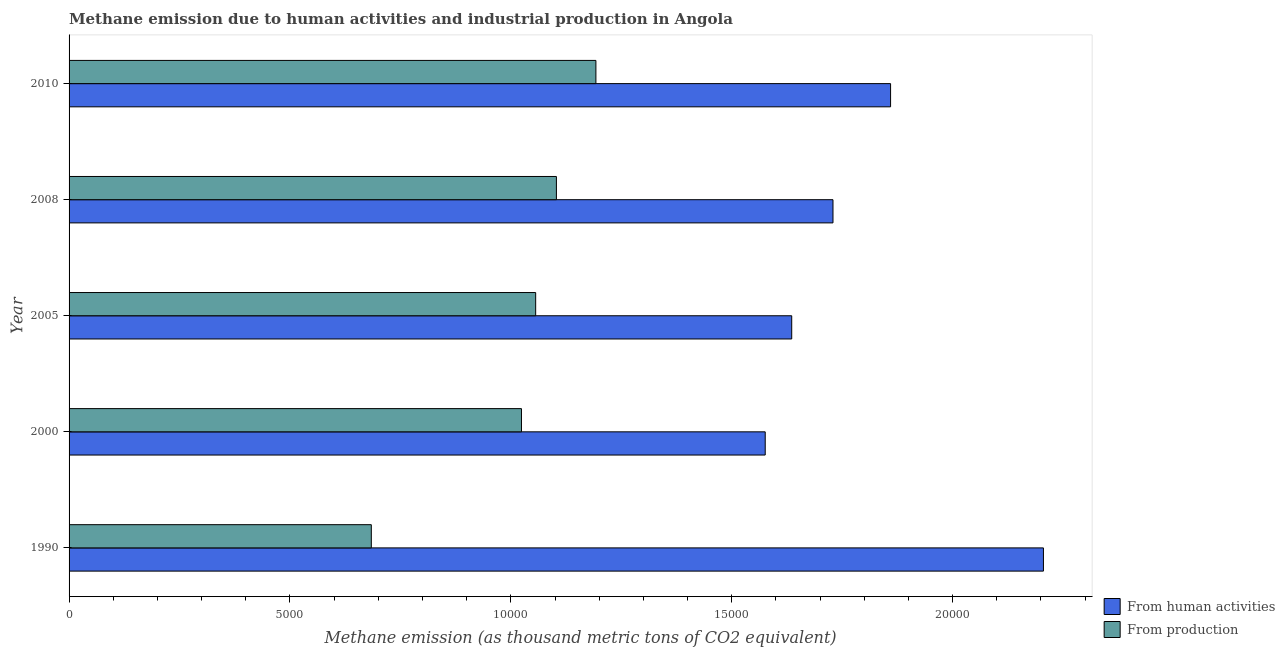Are the number of bars per tick equal to the number of legend labels?
Your response must be concise. Yes. Are the number of bars on each tick of the Y-axis equal?
Make the answer very short. Yes. How many bars are there on the 5th tick from the bottom?
Your answer should be very brief. 2. In how many cases, is the number of bars for a given year not equal to the number of legend labels?
Give a very brief answer. 0. What is the amount of emissions generated from industries in 2005?
Keep it short and to the point. 1.06e+04. Across all years, what is the maximum amount of emissions generated from industries?
Ensure brevity in your answer.  1.19e+04. Across all years, what is the minimum amount of emissions from human activities?
Ensure brevity in your answer.  1.58e+04. In which year was the amount of emissions from human activities minimum?
Your answer should be compact. 2000. What is the total amount of emissions from human activities in the graph?
Offer a terse response. 9.01e+04. What is the difference between the amount of emissions from human activities in 2005 and that in 2008?
Provide a short and direct response. -934.1. What is the difference between the amount of emissions generated from industries in 2005 and the amount of emissions from human activities in 1990?
Ensure brevity in your answer.  -1.15e+04. What is the average amount of emissions from human activities per year?
Offer a terse response. 1.80e+04. In the year 2005, what is the difference between the amount of emissions from human activities and amount of emissions generated from industries?
Ensure brevity in your answer.  5796.3. What is the ratio of the amount of emissions generated from industries in 2005 to that in 2010?
Provide a short and direct response. 0.89. What is the difference between the highest and the second highest amount of emissions generated from industries?
Ensure brevity in your answer.  894.1. What is the difference between the highest and the lowest amount of emissions generated from industries?
Your response must be concise. 5084.3. What does the 2nd bar from the top in 2000 represents?
Offer a very short reply. From human activities. What does the 2nd bar from the bottom in 2010 represents?
Your response must be concise. From production. How many years are there in the graph?
Give a very brief answer. 5. Are the values on the major ticks of X-axis written in scientific E-notation?
Offer a very short reply. No. Does the graph contain any zero values?
Keep it short and to the point. No. Does the graph contain grids?
Ensure brevity in your answer.  No. Where does the legend appear in the graph?
Provide a short and direct response. Bottom right. What is the title of the graph?
Give a very brief answer. Methane emission due to human activities and industrial production in Angola. What is the label or title of the X-axis?
Your response must be concise. Methane emission (as thousand metric tons of CO2 equivalent). What is the Methane emission (as thousand metric tons of CO2 equivalent) of From human activities in 1990?
Offer a terse response. 2.21e+04. What is the Methane emission (as thousand metric tons of CO2 equivalent) of From production in 1990?
Your answer should be compact. 6841.7. What is the Methane emission (as thousand metric tons of CO2 equivalent) in From human activities in 2000?
Offer a very short reply. 1.58e+04. What is the Methane emission (as thousand metric tons of CO2 equivalent) of From production in 2000?
Provide a short and direct response. 1.02e+04. What is the Methane emission (as thousand metric tons of CO2 equivalent) in From human activities in 2005?
Your answer should be compact. 1.64e+04. What is the Methane emission (as thousand metric tons of CO2 equivalent) in From production in 2005?
Provide a succinct answer. 1.06e+04. What is the Methane emission (as thousand metric tons of CO2 equivalent) in From human activities in 2008?
Provide a short and direct response. 1.73e+04. What is the Methane emission (as thousand metric tons of CO2 equivalent) of From production in 2008?
Make the answer very short. 1.10e+04. What is the Methane emission (as thousand metric tons of CO2 equivalent) of From human activities in 2010?
Provide a short and direct response. 1.86e+04. What is the Methane emission (as thousand metric tons of CO2 equivalent) in From production in 2010?
Your answer should be compact. 1.19e+04. Across all years, what is the maximum Methane emission (as thousand metric tons of CO2 equivalent) of From human activities?
Ensure brevity in your answer.  2.21e+04. Across all years, what is the maximum Methane emission (as thousand metric tons of CO2 equivalent) of From production?
Offer a very short reply. 1.19e+04. Across all years, what is the minimum Methane emission (as thousand metric tons of CO2 equivalent) in From human activities?
Your answer should be very brief. 1.58e+04. Across all years, what is the minimum Methane emission (as thousand metric tons of CO2 equivalent) of From production?
Your answer should be compact. 6841.7. What is the total Methane emission (as thousand metric tons of CO2 equivalent) in From human activities in the graph?
Keep it short and to the point. 9.01e+04. What is the total Methane emission (as thousand metric tons of CO2 equivalent) in From production in the graph?
Provide a succinct answer. 5.06e+04. What is the difference between the Methane emission (as thousand metric tons of CO2 equivalent) of From human activities in 1990 and that in 2000?
Provide a short and direct response. 6298. What is the difference between the Methane emission (as thousand metric tons of CO2 equivalent) in From production in 1990 and that in 2000?
Make the answer very short. -3399.1. What is the difference between the Methane emission (as thousand metric tons of CO2 equivalent) of From human activities in 1990 and that in 2005?
Make the answer very short. 5697.9. What is the difference between the Methane emission (as thousand metric tons of CO2 equivalent) of From production in 1990 and that in 2005?
Make the answer very short. -3720.7. What is the difference between the Methane emission (as thousand metric tons of CO2 equivalent) of From human activities in 1990 and that in 2008?
Ensure brevity in your answer.  4763.8. What is the difference between the Methane emission (as thousand metric tons of CO2 equivalent) in From production in 1990 and that in 2008?
Provide a short and direct response. -4190.2. What is the difference between the Methane emission (as thousand metric tons of CO2 equivalent) of From human activities in 1990 and that in 2010?
Make the answer very short. 3460.1. What is the difference between the Methane emission (as thousand metric tons of CO2 equivalent) of From production in 1990 and that in 2010?
Make the answer very short. -5084.3. What is the difference between the Methane emission (as thousand metric tons of CO2 equivalent) in From human activities in 2000 and that in 2005?
Your answer should be compact. -600.1. What is the difference between the Methane emission (as thousand metric tons of CO2 equivalent) of From production in 2000 and that in 2005?
Your answer should be very brief. -321.6. What is the difference between the Methane emission (as thousand metric tons of CO2 equivalent) in From human activities in 2000 and that in 2008?
Your answer should be compact. -1534.2. What is the difference between the Methane emission (as thousand metric tons of CO2 equivalent) in From production in 2000 and that in 2008?
Keep it short and to the point. -791.1. What is the difference between the Methane emission (as thousand metric tons of CO2 equivalent) in From human activities in 2000 and that in 2010?
Offer a very short reply. -2837.9. What is the difference between the Methane emission (as thousand metric tons of CO2 equivalent) of From production in 2000 and that in 2010?
Offer a very short reply. -1685.2. What is the difference between the Methane emission (as thousand metric tons of CO2 equivalent) in From human activities in 2005 and that in 2008?
Your answer should be compact. -934.1. What is the difference between the Methane emission (as thousand metric tons of CO2 equivalent) of From production in 2005 and that in 2008?
Keep it short and to the point. -469.5. What is the difference between the Methane emission (as thousand metric tons of CO2 equivalent) of From human activities in 2005 and that in 2010?
Your answer should be very brief. -2237.8. What is the difference between the Methane emission (as thousand metric tons of CO2 equivalent) of From production in 2005 and that in 2010?
Your response must be concise. -1363.6. What is the difference between the Methane emission (as thousand metric tons of CO2 equivalent) of From human activities in 2008 and that in 2010?
Offer a terse response. -1303.7. What is the difference between the Methane emission (as thousand metric tons of CO2 equivalent) of From production in 2008 and that in 2010?
Offer a very short reply. -894.1. What is the difference between the Methane emission (as thousand metric tons of CO2 equivalent) in From human activities in 1990 and the Methane emission (as thousand metric tons of CO2 equivalent) in From production in 2000?
Offer a very short reply. 1.18e+04. What is the difference between the Methane emission (as thousand metric tons of CO2 equivalent) of From human activities in 1990 and the Methane emission (as thousand metric tons of CO2 equivalent) of From production in 2005?
Provide a short and direct response. 1.15e+04. What is the difference between the Methane emission (as thousand metric tons of CO2 equivalent) in From human activities in 1990 and the Methane emission (as thousand metric tons of CO2 equivalent) in From production in 2008?
Your response must be concise. 1.10e+04. What is the difference between the Methane emission (as thousand metric tons of CO2 equivalent) in From human activities in 1990 and the Methane emission (as thousand metric tons of CO2 equivalent) in From production in 2010?
Offer a terse response. 1.01e+04. What is the difference between the Methane emission (as thousand metric tons of CO2 equivalent) of From human activities in 2000 and the Methane emission (as thousand metric tons of CO2 equivalent) of From production in 2005?
Make the answer very short. 5196.2. What is the difference between the Methane emission (as thousand metric tons of CO2 equivalent) in From human activities in 2000 and the Methane emission (as thousand metric tons of CO2 equivalent) in From production in 2008?
Provide a succinct answer. 4726.7. What is the difference between the Methane emission (as thousand metric tons of CO2 equivalent) of From human activities in 2000 and the Methane emission (as thousand metric tons of CO2 equivalent) of From production in 2010?
Offer a terse response. 3832.6. What is the difference between the Methane emission (as thousand metric tons of CO2 equivalent) in From human activities in 2005 and the Methane emission (as thousand metric tons of CO2 equivalent) in From production in 2008?
Make the answer very short. 5326.8. What is the difference between the Methane emission (as thousand metric tons of CO2 equivalent) of From human activities in 2005 and the Methane emission (as thousand metric tons of CO2 equivalent) of From production in 2010?
Provide a short and direct response. 4432.7. What is the difference between the Methane emission (as thousand metric tons of CO2 equivalent) in From human activities in 2008 and the Methane emission (as thousand metric tons of CO2 equivalent) in From production in 2010?
Your answer should be compact. 5366.8. What is the average Methane emission (as thousand metric tons of CO2 equivalent) of From human activities per year?
Make the answer very short. 1.80e+04. What is the average Methane emission (as thousand metric tons of CO2 equivalent) in From production per year?
Offer a terse response. 1.01e+04. In the year 1990, what is the difference between the Methane emission (as thousand metric tons of CO2 equivalent) of From human activities and Methane emission (as thousand metric tons of CO2 equivalent) of From production?
Give a very brief answer. 1.52e+04. In the year 2000, what is the difference between the Methane emission (as thousand metric tons of CO2 equivalent) of From human activities and Methane emission (as thousand metric tons of CO2 equivalent) of From production?
Offer a very short reply. 5517.8. In the year 2005, what is the difference between the Methane emission (as thousand metric tons of CO2 equivalent) in From human activities and Methane emission (as thousand metric tons of CO2 equivalent) in From production?
Provide a succinct answer. 5796.3. In the year 2008, what is the difference between the Methane emission (as thousand metric tons of CO2 equivalent) in From human activities and Methane emission (as thousand metric tons of CO2 equivalent) in From production?
Offer a very short reply. 6260.9. In the year 2010, what is the difference between the Methane emission (as thousand metric tons of CO2 equivalent) in From human activities and Methane emission (as thousand metric tons of CO2 equivalent) in From production?
Your answer should be very brief. 6670.5. What is the ratio of the Methane emission (as thousand metric tons of CO2 equivalent) of From human activities in 1990 to that in 2000?
Your answer should be very brief. 1.4. What is the ratio of the Methane emission (as thousand metric tons of CO2 equivalent) in From production in 1990 to that in 2000?
Keep it short and to the point. 0.67. What is the ratio of the Methane emission (as thousand metric tons of CO2 equivalent) in From human activities in 1990 to that in 2005?
Offer a very short reply. 1.35. What is the ratio of the Methane emission (as thousand metric tons of CO2 equivalent) of From production in 1990 to that in 2005?
Keep it short and to the point. 0.65. What is the ratio of the Methane emission (as thousand metric tons of CO2 equivalent) of From human activities in 1990 to that in 2008?
Your response must be concise. 1.28. What is the ratio of the Methane emission (as thousand metric tons of CO2 equivalent) in From production in 1990 to that in 2008?
Provide a succinct answer. 0.62. What is the ratio of the Methane emission (as thousand metric tons of CO2 equivalent) of From human activities in 1990 to that in 2010?
Provide a succinct answer. 1.19. What is the ratio of the Methane emission (as thousand metric tons of CO2 equivalent) of From production in 1990 to that in 2010?
Make the answer very short. 0.57. What is the ratio of the Methane emission (as thousand metric tons of CO2 equivalent) in From human activities in 2000 to that in 2005?
Give a very brief answer. 0.96. What is the ratio of the Methane emission (as thousand metric tons of CO2 equivalent) in From production in 2000 to that in 2005?
Your response must be concise. 0.97. What is the ratio of the Methane emission (as thousand metric tons of CO2 equivalent) of From human activities in 2000 to that in 2008?
Offer a terse response. 0.91. What is the ratio of the Methane emission (as thousand metric tons of CO2 equivalent) in From production in 2000 to that in 2008?
Provide a short and direct response. 0.93. What is the ratio of the Methane emission (as thousand metric tons of CO2 equivalent) in From human activities in 2000 to that in 2010?
Make the answer very short. 0.85. What is the ratio of the Methane emission (as thousand metric tons of CO2 equivalent) of From production in 2000 to that in 2010?
Provide a succinct answer. 0.86. What is the ratio of the Methane emission (as thousand metric tons of CO2 equivalent) in From human activities in 2005 to that in 2008?
Provide a short and direct response. 0.95. What is the ratio of the Methane emission (as thousand metric tons of CO2 equivalent) in From production in 2005 to that in 2008?
Ensure brevity in your answer.  0.96. What is the ratio of the Methane emission (as thousand metric tons of CO2 equivalent) of From human activities in 2005 to that in 2010?
Your response must be concise. 0.88. What is the ratio of the Methane emission (as thousand metric tons of CO2 equivalent) in From production in 2005 to that in 2010?
Make the answer very short. 0.89. What is the ratio of the Methane emission (as thousand metric tons of CO2 equivalent) in From human activities in 2008 to that in 2010?
Ensure brevity in your answer.  0.93. What is the ratio of the Methane emission (as thousand metric tons of CO2 equivalent) in From production in 2008 to that in 2010?
Give a very brief answer. 0.93. What is the difference between the highest and the second highest Methane emission (as thousand metric tons of CO2 equivalent) in From human activities?
Make the answer very short. 3460.1. What is the difference between the highest and the second highest Methane emission (as thousand metric tons of CO2 equivalent) in From production?
Offer a very short reply. 894.1. What is the difference between the highest and the lowest Methane emission (as thousand metric tons of CO2 equivalent) in From human activities?
Provide a short and direct response. 6298. What is the difference between the highest and the lowest Methane emission (as thousand metric tons of CO2 equivalent) of From production?
Your response must be concise. 5084.3. 